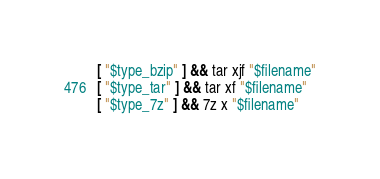Convert code to text. <code><loc_0><loc_0><loc_500><loc_500><_Bash_>[ "$type_bzip" ] && tar xjf "$filename"
[ "$type_tar" ] && tar xf "$filename"
[ "$type_7z" ] && 7z x "$filename"
</code> 